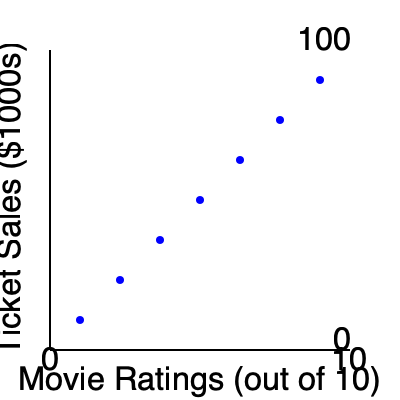As a movie critic in a small town, you've been tracking the relationship between movie ratings and ticket sales. Based on the scatter plot, what type of correlation exists between movie ratings and ticket sales in your local theater? To determine the type of correlation between movie ratings and ticket sales, we need to analyze the pattern of the data points in the scatter plot:

1. Observe the overall trend: As we move from left to right (increasing movie ratings), the data points tend to move upward (increasing ticket sales).

2. Check for linearity: The points roughly form a straight line, suggesting a linear relationship.

3. Assess the direction: The line slopes upward from left to right, indicating a positive relationship.

4. Evaluate the strength: The points are relatively close to an imaginary line that could be drawn through them, suggesting a strong relationship.

5. Consider outliers: There are no significant outliers that deviate from the general trend.

Given these observations, we can conclude that there is a strong positive linear correlation between movie ratings and ticket sales in the small-town theater.

This correlation suggests that as movie ratings increase, ticket sales tend to increase as well, which is valuable information for a movie critic and small-town resident analyzing local cinema trends.
Answer: Strong positive linear correlation 